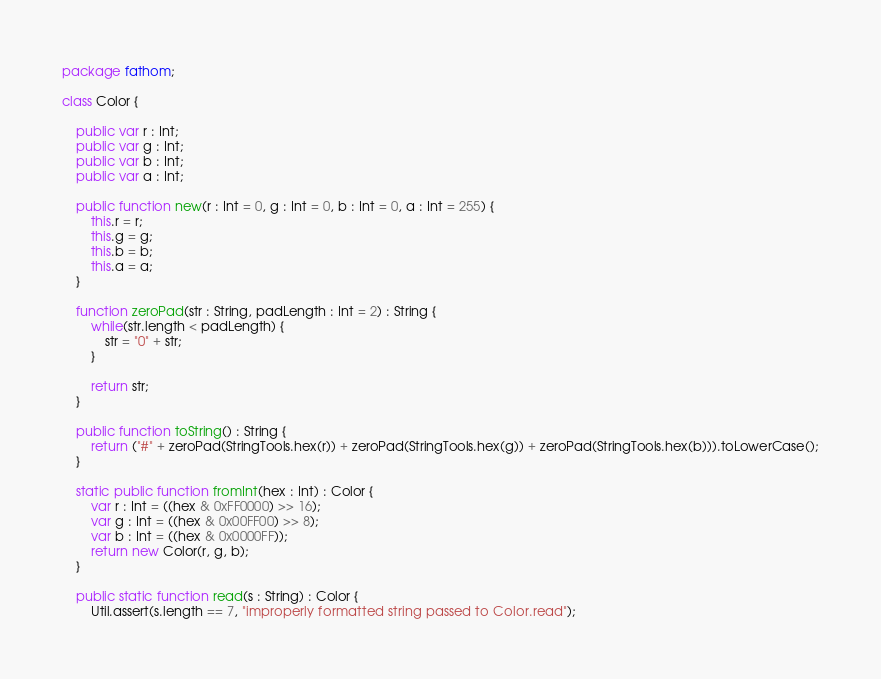Convert code to text. <code><loc_0><loc_0><loc_500><loc_500><_Haxe_>package fathom;

class Color {

    public var r : Int;
    public var g : Int;
    public var b : Int;
    public var a : Int;

    public function new(r : Int = 0, g : Int = 0, b : Int = 0, a : Int = 255) {
        this.r = r;
        this.g = g;
        this.b = b;
        this.a = a;
    }

    function zeroPad(str : String, padLength : Int = 2) : String {
        while(str.length < padLength) {
            str = "0" + str;
        }

        return str;
    }

    public function toString() : String {
        return ("#" + zeroPad(StringTools.hex(r)) + zeroPad(StringTools.hex(g)) + zeroPad(StringTools.hex(b))).toLowerCase();
    }

    static public function fromInt(hex : Int) : Color {
        var r : Int = ((hex & 0xFF0000) >> 16);
        var g : Int = ((hex & 0x00FF00) >> 8);
        var b : Int = ((hex & 0x0000FF));
        return new Color(r, g, b);
    }

    public static function read(s : String) : Color {
        Util.assert(s.length == 7, "improperly formatted string passed to Color.read");
</code> 